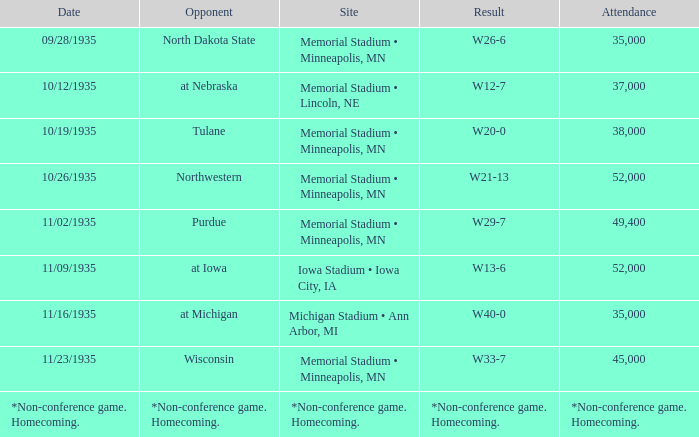How many spectators attended the game that ended in a result of w29-7? 49400.0. 